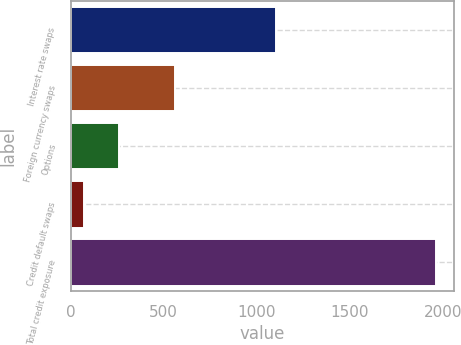Convert chart. <chart><loc_0><loc_0><loc_500><loc_500><bar_chart><fcel>Interest rate swaps<fcel>Foreign currency swaps<fcel>Options<fcel>Credit default swaps<fcel>Total credit exposure<nl><fcel>1105.1<fcel>562.5<fcel>259.69<fcel>70.7<fcel>1960.6<nl></chart> 